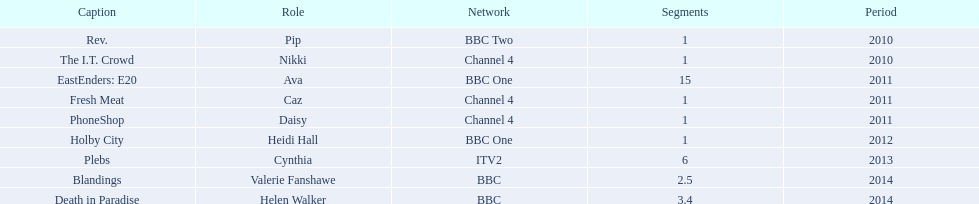What roles did she play? Pip, Nikki, Ava, Caz, Daisy, Heidi Hall, Cynthia, Valerie Fanshawe, Helen Walker. On which broadcasters? BBC Two, Channel 4, BBC One, Channel 4, Channel 4, BBC One, ITV2, BBC, BBC. Which roles did she play for itv2? Cynthia. 